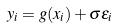Convert formula to latex. <formula><loc_0><loc_0><loc_500><loc_500>y _ { i } = g ( x _ { i } ) + \sigma \epsilon _ { i }</formula> 